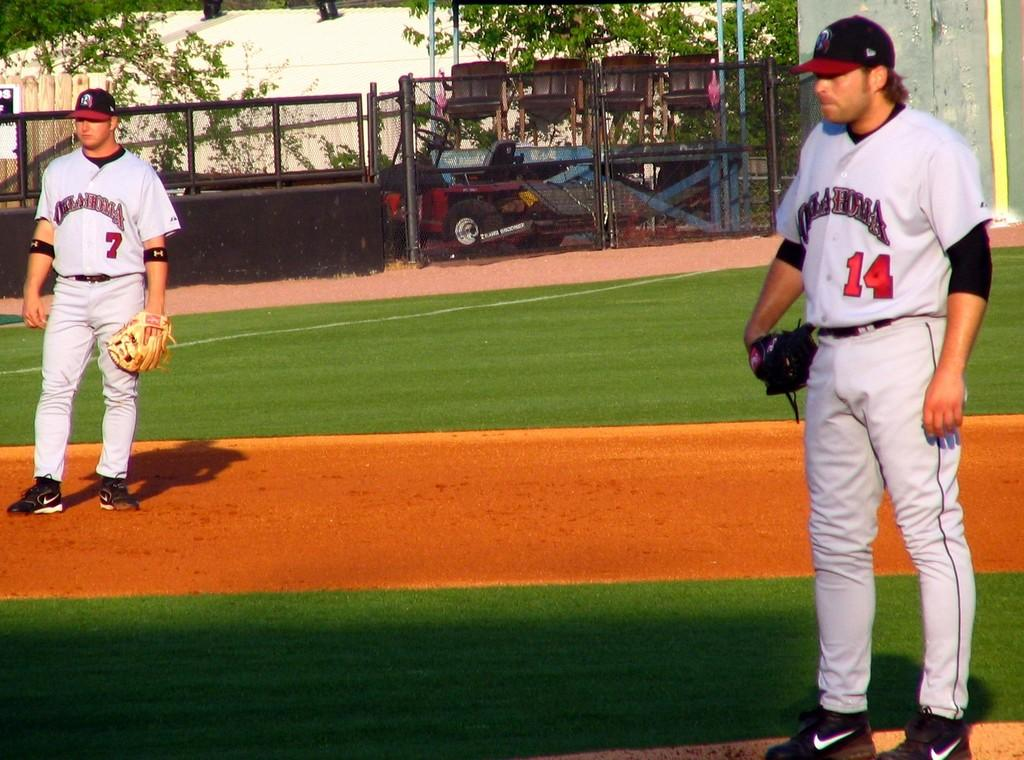<image>
Offer a succinct explanation of the picture presented. Oklahoma's pitcher is standing on the mound, with the third baseman to his right. 